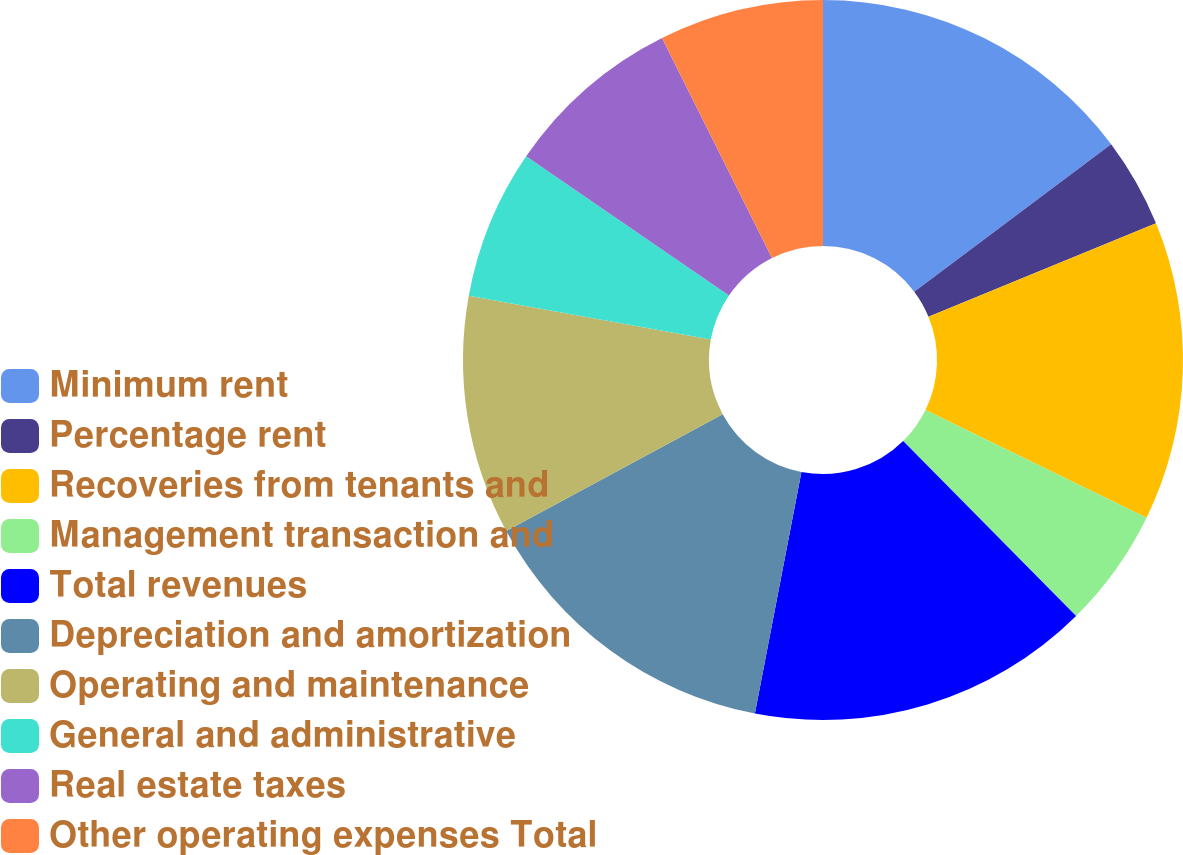Convert chart to OTSL. <chart><loc_0><loc_0><loc_500><loc_500><pie_chart><fcel>Minimum rent<fcel>Percentage rent<fcel>Recoveries from tenants and<fcel>Management transaction and<fcel>Total revenues<fcel>Depreciation and amortization<fcel>Operating and maintenance<fcel>General and administrative<fcel>Real estate taxes<fcel>Other operating expenses Total<nl><fcel>14.77%<fcel>4.03%<fcel>13.42%<fcel>5.37%<fcel>15.44%<fcel>14.09%<fcel>10.74%<fcel>6.71%<fcel>8.05%<fcel>7.38%<nl></chart> 